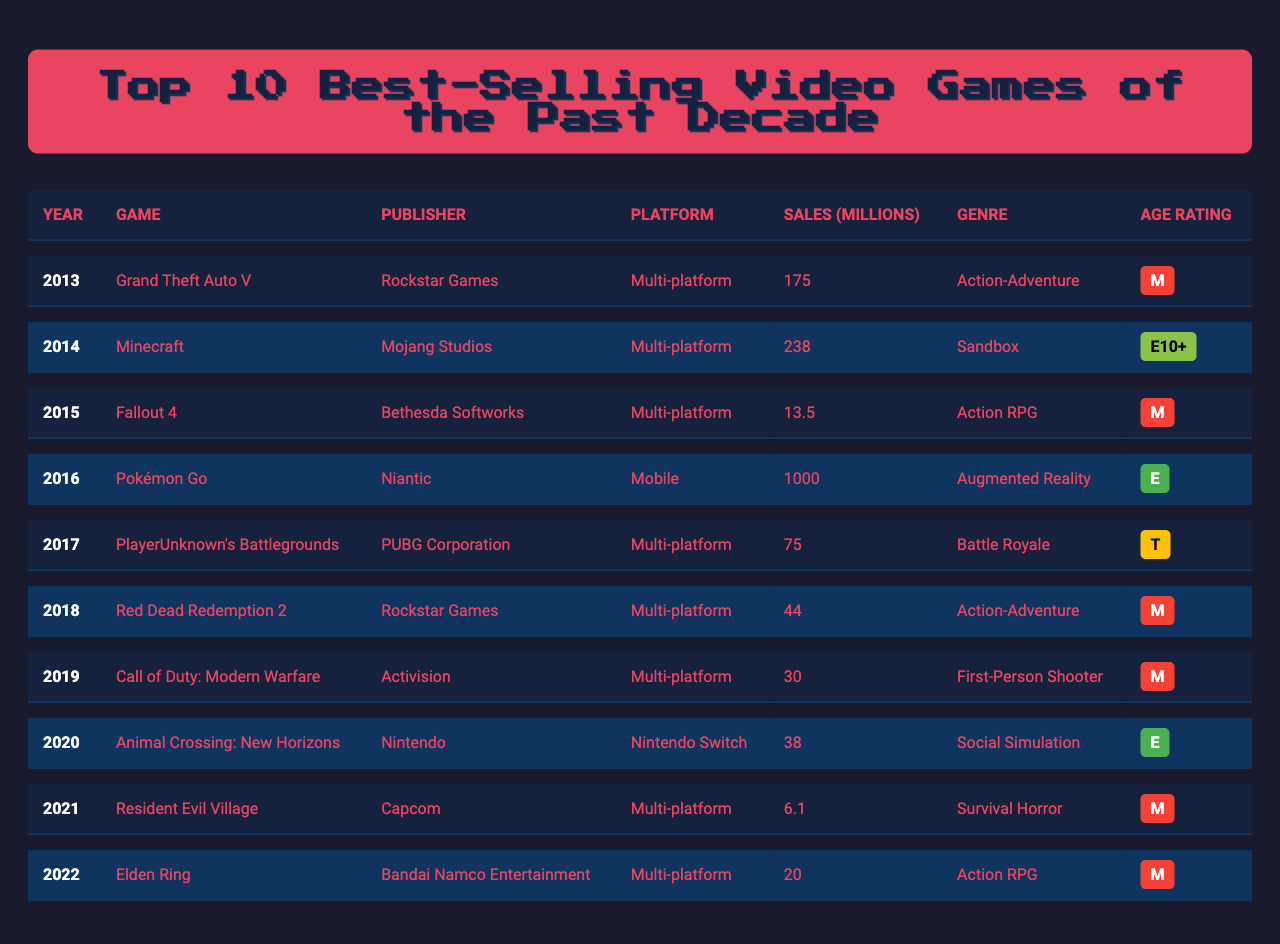What was the best-selling video game of 2013? The table shows that "Grand Theft Auto V" was released in 2013 and has the highest sales at 175 million.
Answer: Grand Theft Auto V Which game had the highest sales in the year 2014? In 2014, "Minecraft" is listed with sales of 238 million, which is the highest for that year.
Answer: Minecraft What is the total sales in millions for the games released from 2015 to 2019? Adding the sales figures for each year from 2015 to 2019: 13.5 (Fallout 4) + 75 (PlayerUnknown's Battlegrounds) + 44 (Red Dead Redemption 2) + 30 (Call of Duty: Modern Warfare) + 38 (Animal Crossing: New Horizons) gives a total of 200.5 million.
Answer: 200.5 What is the age rating for "Elden Ring"? According to the table, "Elden Ring" has an age rating of M (Mature).
Answer: M How many games listed have an age rating of Mature (M)? Reviewing the age ratings, the games with an M rating are "Grand Theft Auto V," "Fallout 4," "Red Dead Redemption 2," "Call of Duty: Modern Warfare," "Resident Evil Village," and "Elden Ring." This totals to 6 games with an M rating.
Answer: 6 Which platform had the highest sales game listed in 2016? In 2016, "Pokémon Go," released on Mobile, had the highest sales at 1000 million, indicating it was the leading platform that year.
Answer: Mobile What is the difference in sales between the best-selling game of 2013 and the best-selling game of 2020? The difference in sales is calculated as follows: 175 million (Grand Theft Auto V) - 38 million (Animal Crossing: New Horizons) = 137 million.
Answer: 137 How many games listed are from Rockstar Games? "Grand Theft Auto V" and "Red Dead Redemption 2" are both published by Rockstar Games, making a total of 2 games from this publisher.
Answer: 2 Which year saw a significant rise in sales with a game exceeding 100 million? The year 2016 saw "Pokémon Go," with sales reaching 1000 million, indicating a significant rise in sales for that year.
Answer: 2016 What genre is the game "PlayerUnknown's Battlegrounds"? The table specifies that "PlayerUnknown's Battlegrounds" is classified under the genre of Battle Royale.
Answer: Battle Royale Which two games were published by Activision and Niantic, respectively? "Call of Duty: Modern Warfare" was published by Activision, and "Pokémon Go" was published by Niantic, as indicated in the publisher column of the table.
Answer: Call of Duty: Modern Warfare & Pokémon Go 